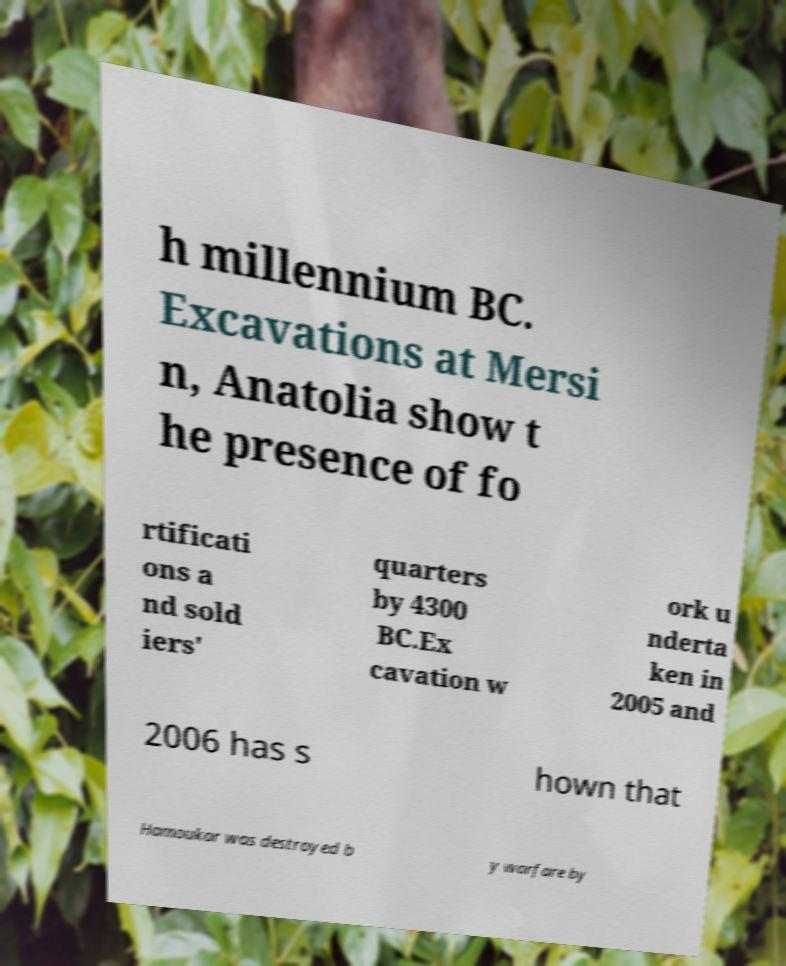Please read and relay the text visible in this image. What does it say? h millennium BC. Excavations at Mersi n, Anatolia show t he presence of fo rtificati ons a nd sold iers' quarters by 4300 BC.Ex cavation w ork u nderta ken in 2005 and 2006 has s hown that Hamoukar was destroyed b y warfare by 